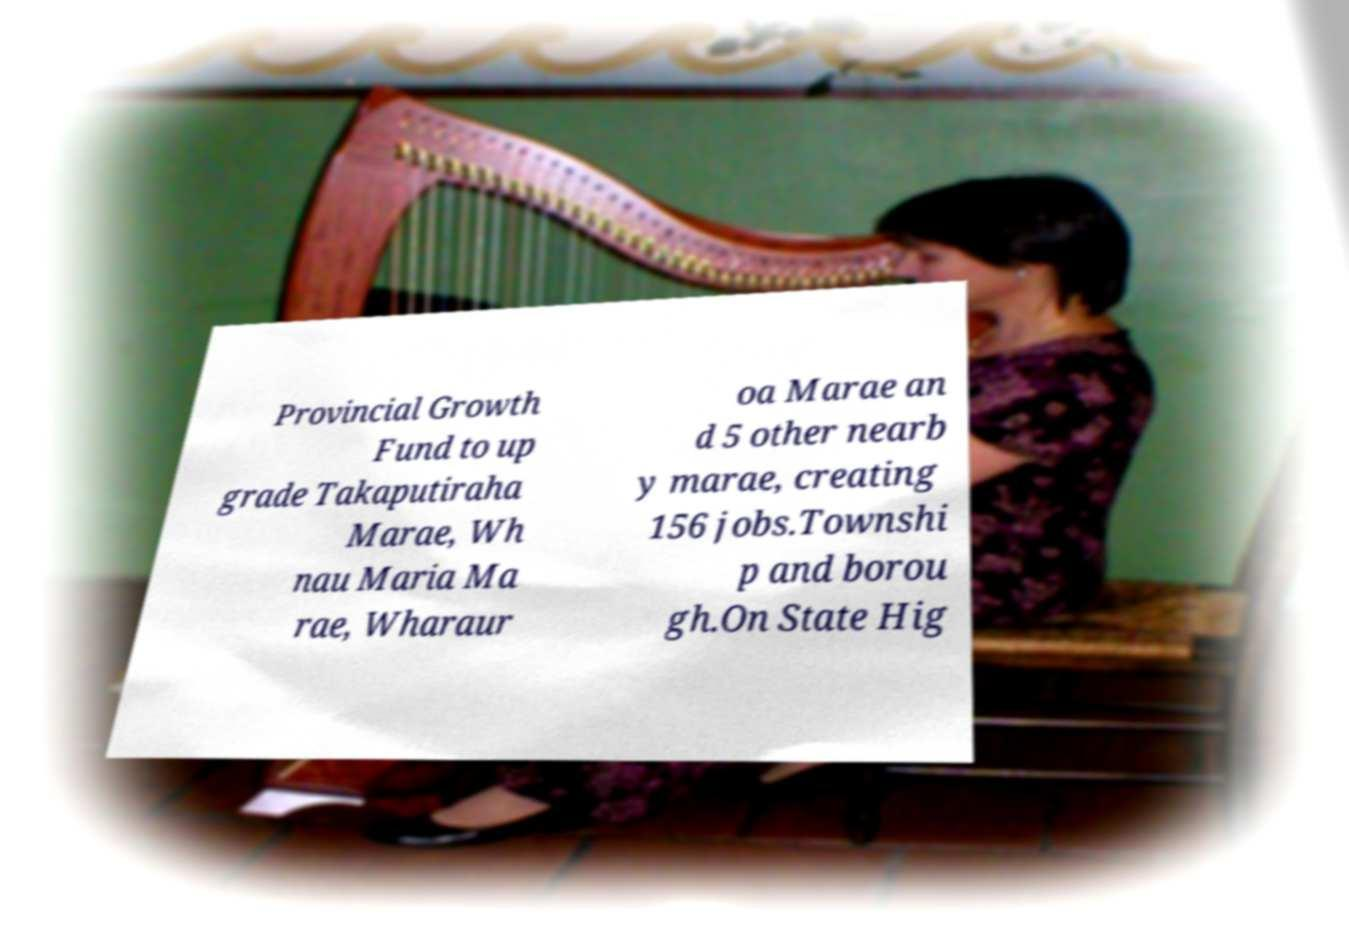Can you accurately transcribe the text from the provided image for me? Provincial Growth Fund to up grade Takaputiraha Marae, Wh nau Maria Ma rae, Wharaur oa Marae an d 5 other nearb y marae, creating 156 jobs.Townshi p and borou gh.On State Hig 